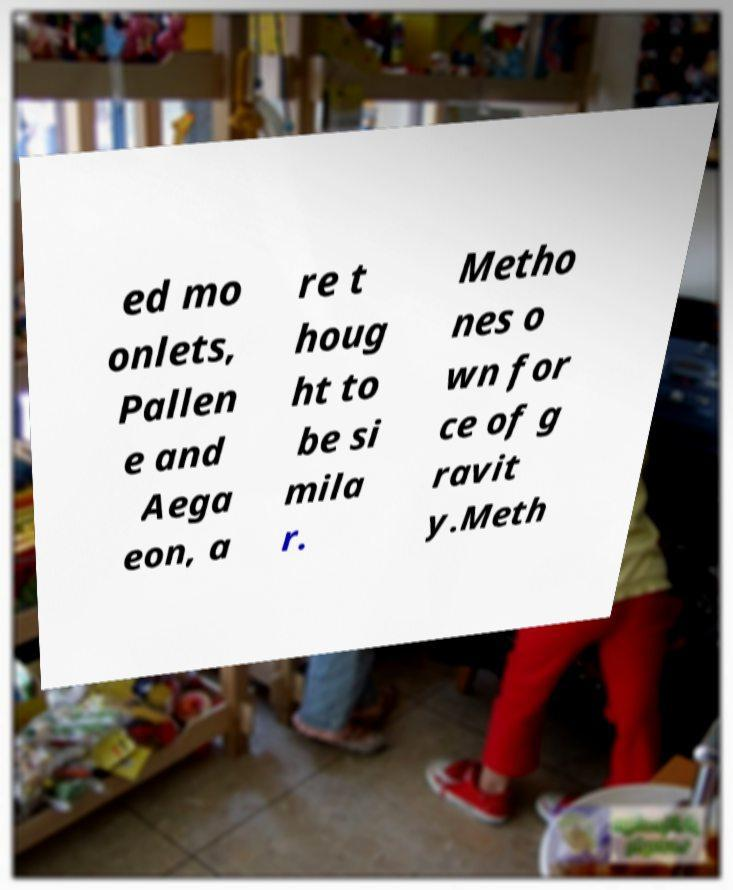I need the written content from this picture converted into text. Can you do that? ed mo onlets, Pallen e and Aega eon, a re t houg ht to be si mila r. Metho nes o wn for ce of g ravit y.Meth 